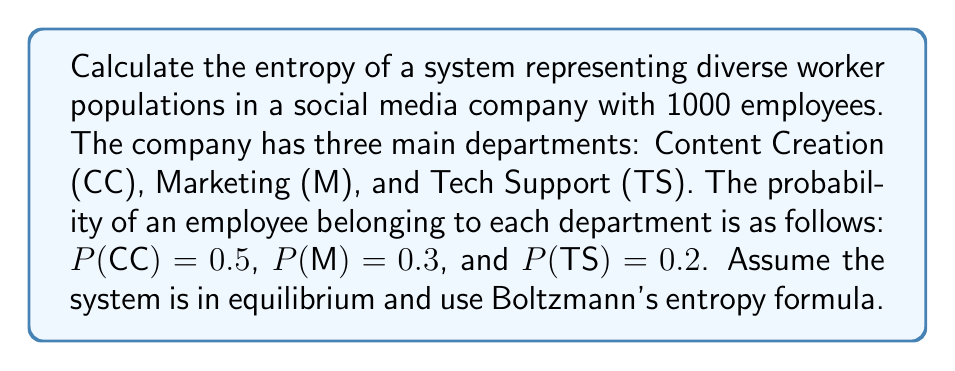Could you help me with this problem? To calculate the entropy of this system, we'll use Boltzmann's entropy formula:

$$ S = -k_B \sum_{i} p_i \ln(p_i) $$

Where:
- $S$ is the entropy
- $k_B$ is Boltzmann's constant (we'll use 1 for simplicity)
- $p_i$ is the probability of the system being in the i-th microstate

Step 1: Identify the probabilities for each department
- P(CC) = 0.5
- P(M) = 0.3
- P(TS) = 0.2

Step 2: Calculate each term in the sum
- For CC: $-0.5 \ln(0.5) = 0.34657$
- For M: $-0.3 \ln(0.3) = 0.36119$
- For TS: $-0.2 \ln(0.2) = 0.32189$

Step 3: Sum up all terms
$$ S = 0.34657 + 0.36119 + 0.32189 = 1.02965 $$

Therefore, the entropy of the system is approximately 1.02965 units.
Answer: 1.02965 units 